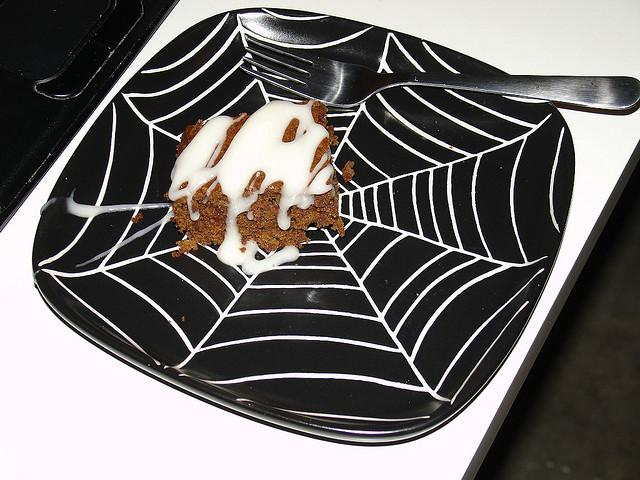What design is painted onto the plate?

Choices:
A) crisscross
B) checkers
C) chevron
D) spider web spider web 